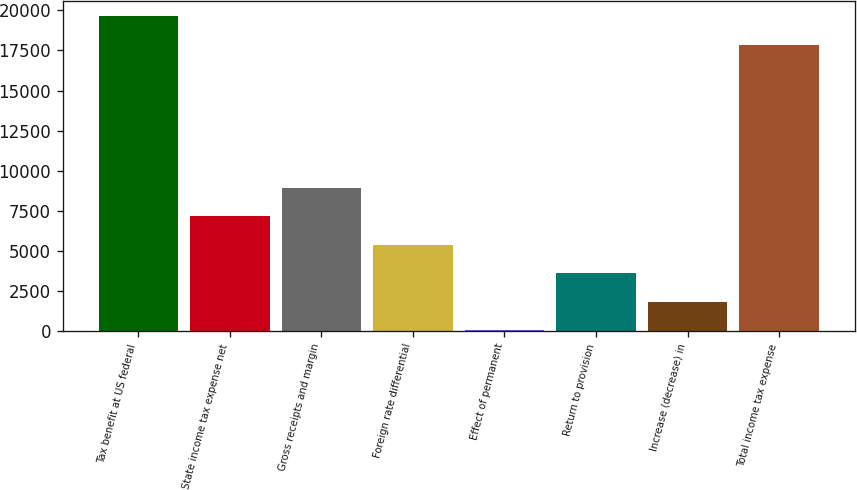Convert chart. <chart><loc_0><loc_0><loc_500><loc_500><bar_chart><fcel>Tax benefit at US federal<fcel>State income tax expense net<fcel>Gross receipts and margin<fcel>Foreign rate differential<fcel>Effect of permanent<fcel>Return to provision<fcel>Increase (decrease) in<fcel>Total income tax expense<nl><fcel>19636.3<fcel>7163.2<fcel>8945.5<fcel>5380.9<fcel>34<fcel>3598.6<fcel>1816.3<fcel>17854<nl></chart> 